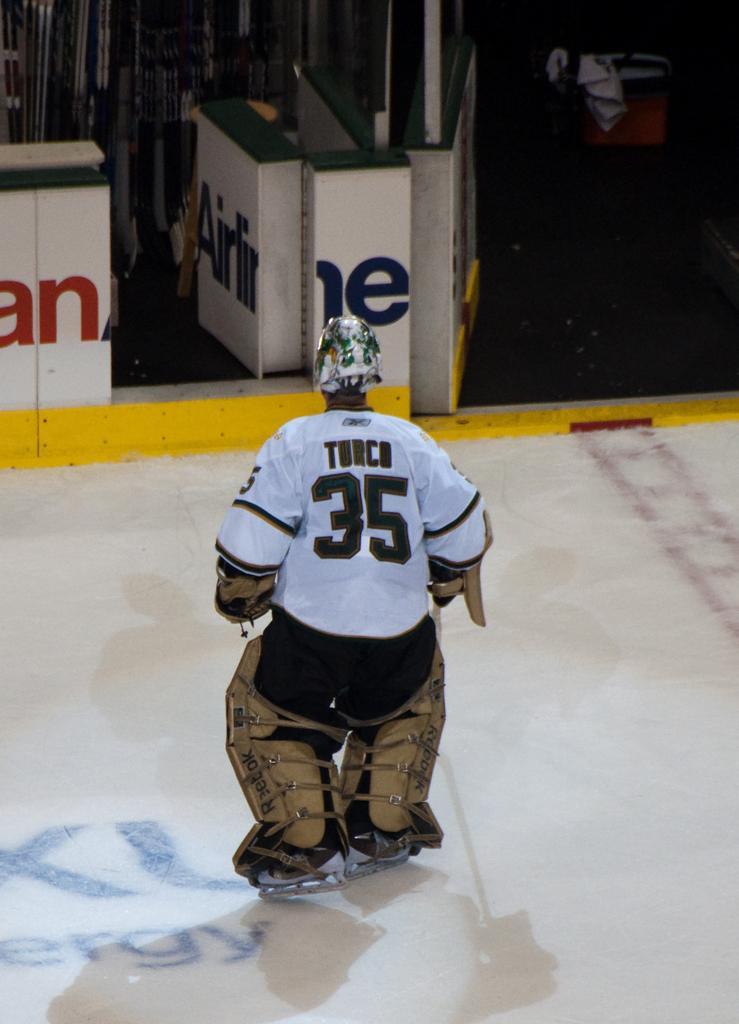How would you summarize this image in a sentence or two? In the center of the image we can see a person. In the background there are boards and we can see some objects. 